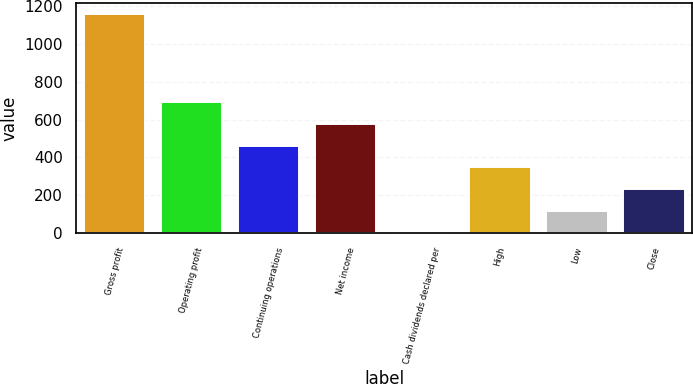Convert chart to OTSL. <chart><loc_0><loc_0><loc_500><loc_500><bar_chart><fcel>Gross profit<fcel>Operating profit<fcel>Continuing operations<fcel>Net income<fcel>Cash dividends declared per<fcel>High<fcel>Low<fcel>Close<nl><fcel>1156.4<fcel>694.05<fcel>462.85<fcel>578.45<fcel>0.45<fcel>347.25<fcel>116.05<fcel>231.65<nl></chart> 